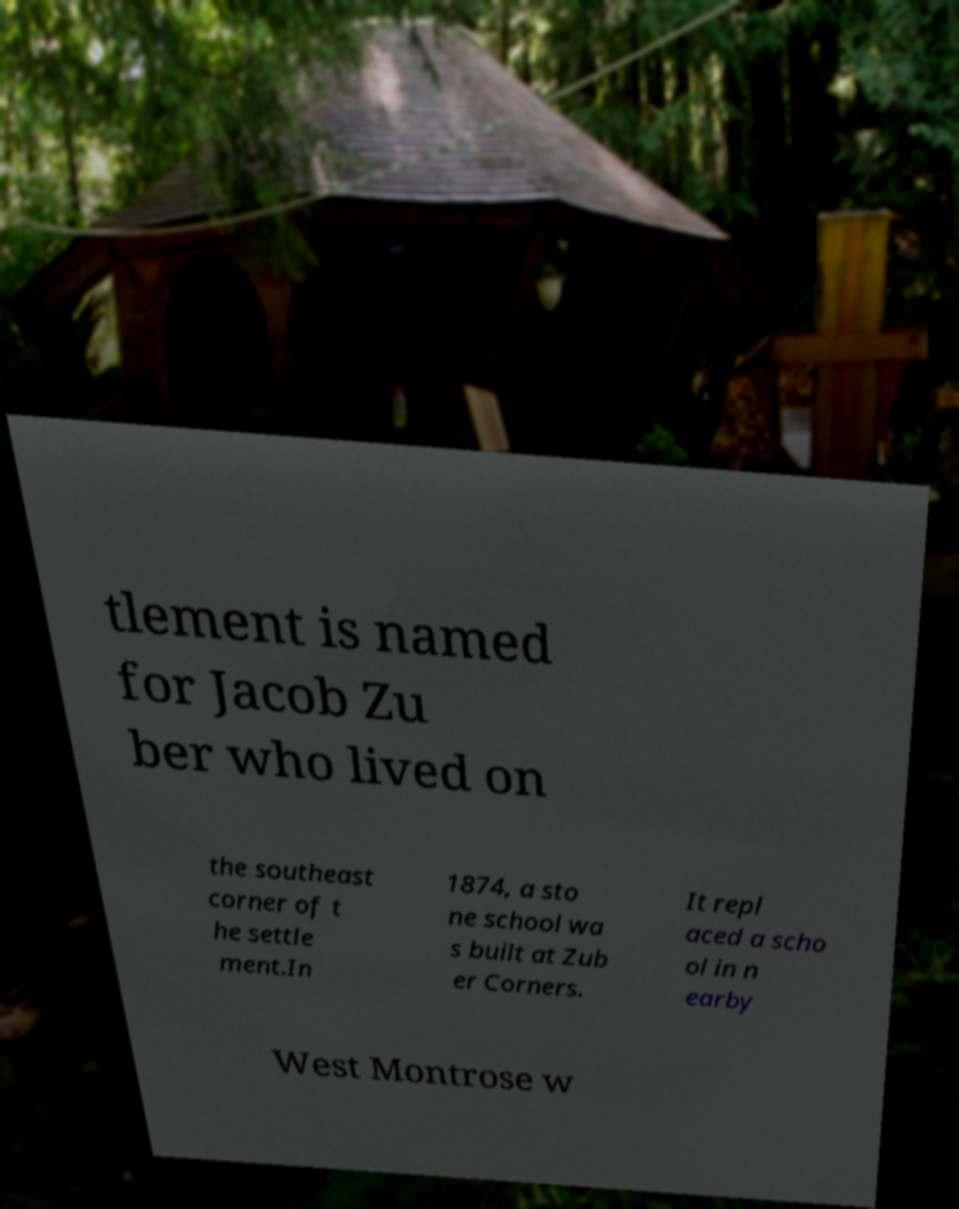For documentation purposes, I need the text within this image transcribed. Could you provide that? tlement is named for Jacob Zu ber who lived on the southeast corner of t he settle ment.In 1874, a sto ne school wa s built at Zub er Corners. It repl aced a scho ol in n earby West Montrose w 